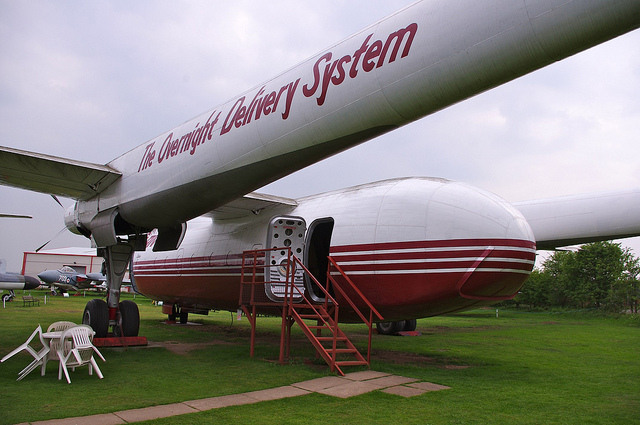Please identify all text content in this image. The Overnight Delivery System 